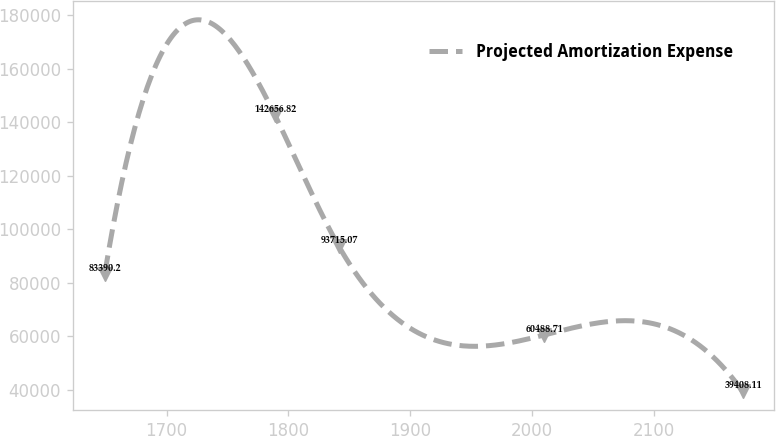<chart> <loc_0><loc_0><loc_500><loc_500><line_chart><ecel><fcel>Projected Amortization Expense<nl><fcel>1649.29<fcel>83390.2<nl><fcel>1788.93<fcel>142657<nl><fcel>1841.28<fcel>93715.1<nl><fcel>2009.83<fcel>60488.7<nl><fcel>2172.76<fcel>39408.1<nl></chart> 